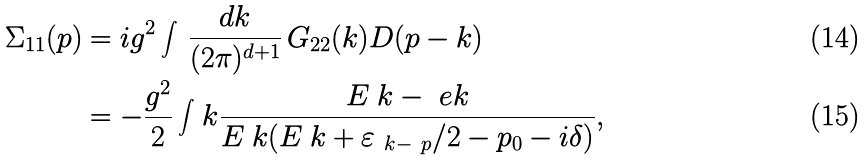<formula> <loc_0><loc_0><loc_500><loc_500>\Sigma _ { 1 1 } ( p ) & = i g ^ { 2 } \int \, \frac { d k } { ( 2 \pi ) ^ { d + 1 } } \, G _ { 2 2 } ( k ) D ( p - k ) \\ & = - \frac { g ^ { 2 } } 2 \int _ { \ } k \frac { E _ { \ } k - \ e k } { E _ { \ } k ( E _ { \ } k + \varepsilon _ { \ k - \ p } / 2 - p _ { 0 } - i \delta ) } ,</formula> 